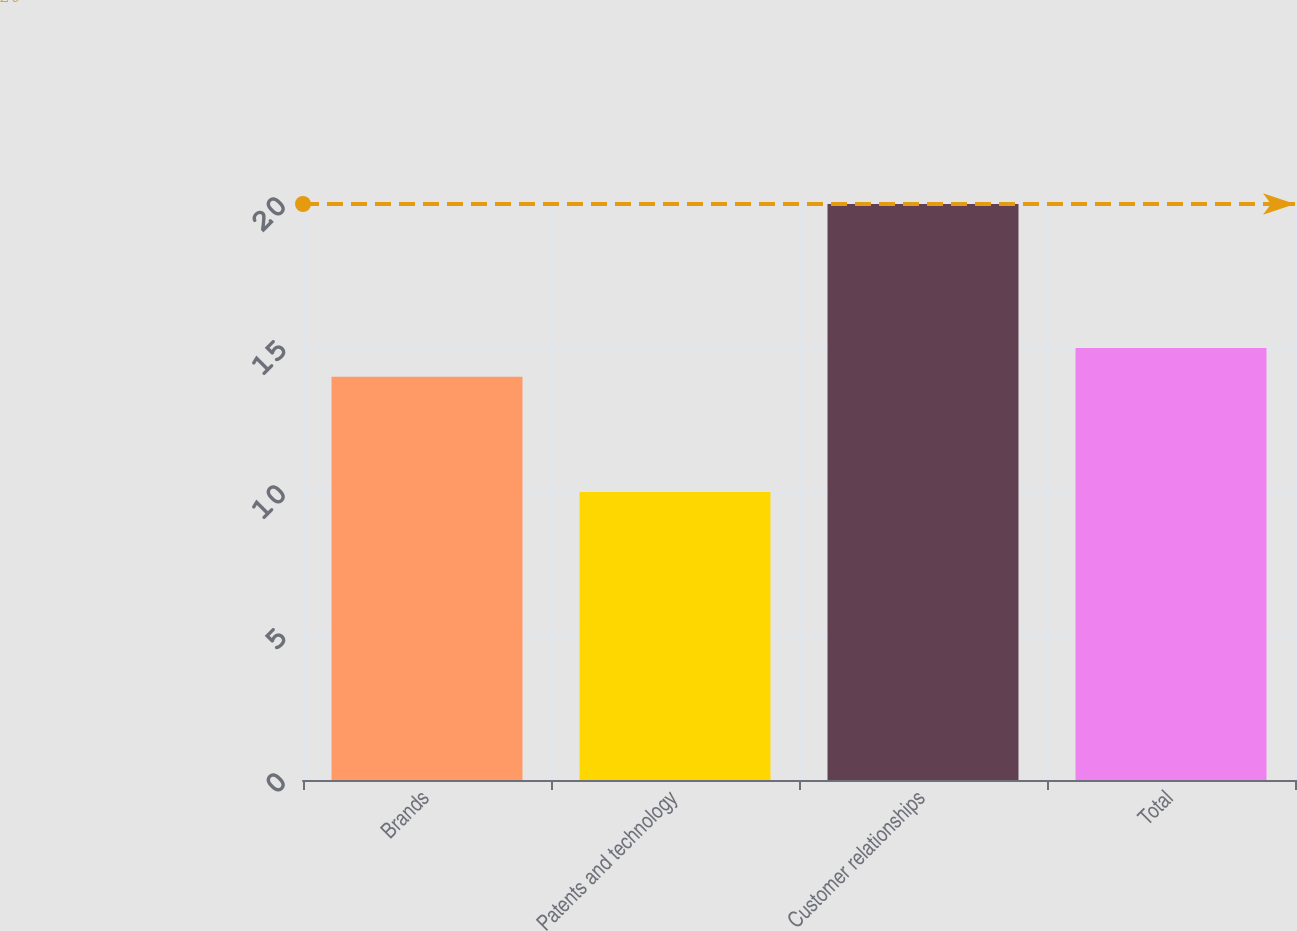Convert chart to OTSL. <chart><loc_0><loc_0><loc_500><loc_500><bar_chart><fcel>Brands<fcel>Patents and technology<fcel>Customer relationships<fcel>Total<nl><fcel>14<fcel>10<fcel>20<fcel>15<nl></chart> 